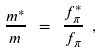Convert formula to latex. <formula><loc_0><loc_0><loc_500><loc_500>\frac { m ^ { * } } m \ = \ \frac { f ^ { * } _ { \pi } } { f _ { \pi } } \ ,</formula> 